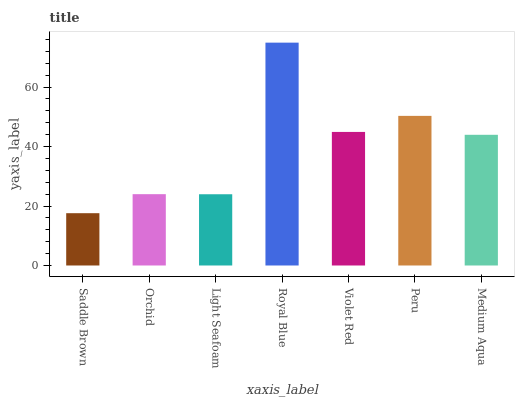Is Saddle Brown the minimum?
Answer yes or no. Yes. Is Royal Blue the maximum?
Answer yes or no. Yes. Is Orchid the minimum?
Answer yes or no. No. Is Orchid the maximum?
Answer yes or no. No. Is Orchid greater than Saddle Brown?
Answer yes or no. Yes. Is Saddle Brown less than Orchid?
Answer yes or no. Yes. Is Saddle Brown greater than Orchid?
Answer yes or no. No. Is Orchid less than Saddle Brown?
Answer yes or no. No. Is Medium Aqua the high median?
Answer yes or no. Yes. Is Medium Aqua the low median?
Answer yes or no. Yes. Is Royal Blue the high median?
Answer yes or no. No. Is Peru the low median?
Answer yes or no. No. 